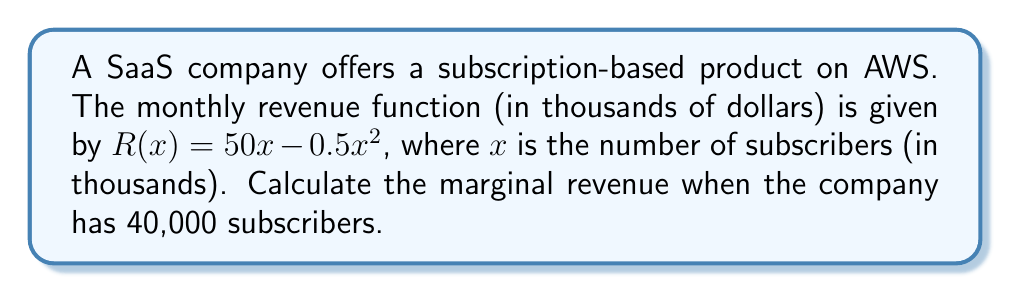Help me with this question. To solve this problem, we'll follow these steps:

1. Understand the given information:
   - Revenue function: $R(x) = 50x - 0.5x^2$ (in thousands of dollars)
   - $x$ is in thousands of subscribers
   - We need to find marginal revenue at 40,000 subscribers

2. Convert 40,000 subscribers to the correct units:
   40,000 subscribers = 40 thousand subscribers

3. Recall that marginal revenue is the derivative of the revenue function:
   $MR(x) = \frac{dR}{dx} = R'(x)$

4. Calculate the derivative of the revenue function:
   $$\begin{align}
   R(x) &= 50x - 0.5x^2 \\
   R'(x) &= 50 - x
   \end{align}$$

5. Substitute $x = 40$ into the marginal revenue function:
   $$\begin{align}
   MR(40) &= 50 - 40 \\
   &= 10
   \end{align}$$

6. Interpret the result:
   The marginal revenue is 10 thousand dollars, or $10,000.
Answer: $10,000 